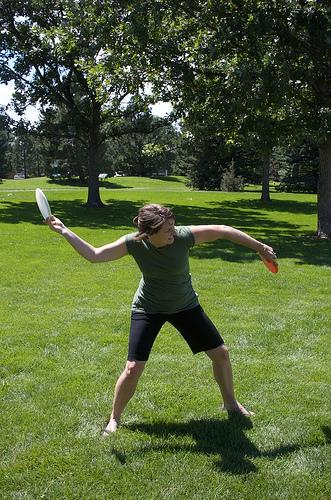What is this woman trying to hit?

Choices:
A) person
B) ball
C) target
D) puck ball 